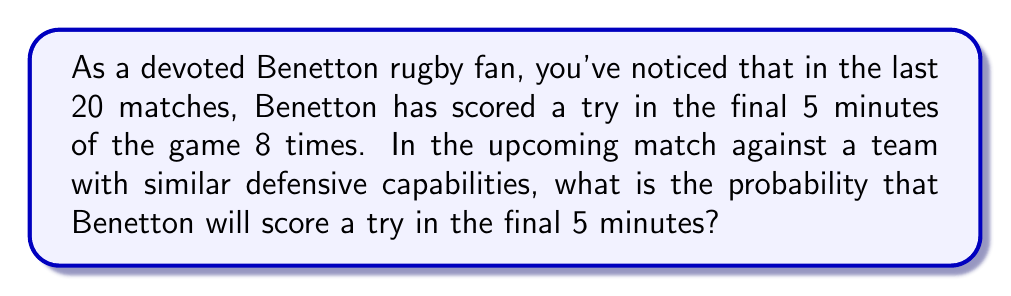Solve this math problem. To solve this problem, we'll use the concept of relative frequency as an estimate of probability. The relative frequency of an event is calculated by dividing the number of times the event occurs by the total number of trials.

Let's define our variables:
$n$ = number of times Benetton scored a try in the final 5 minutes
$N$ = total number of matches observed

Given:
$n = 8$
$N = 20$

The probability $p$ can be estimated as:

$$p = \frac{n}{N} = \frac{8}{20} = 0.4$$

To express this as a percentage:

$$p(\%) = 0.4 \times 100\% = 40\%$$

It's important to note that this is an estimate based on past performance and assumes that the conditions of the upcoming match are similar to those of the past 20 matches.
Answer: The probability that Benetton will score a try in the final 5 minutes of the upcoming match is approximately $0.4$ or $40\%$. 